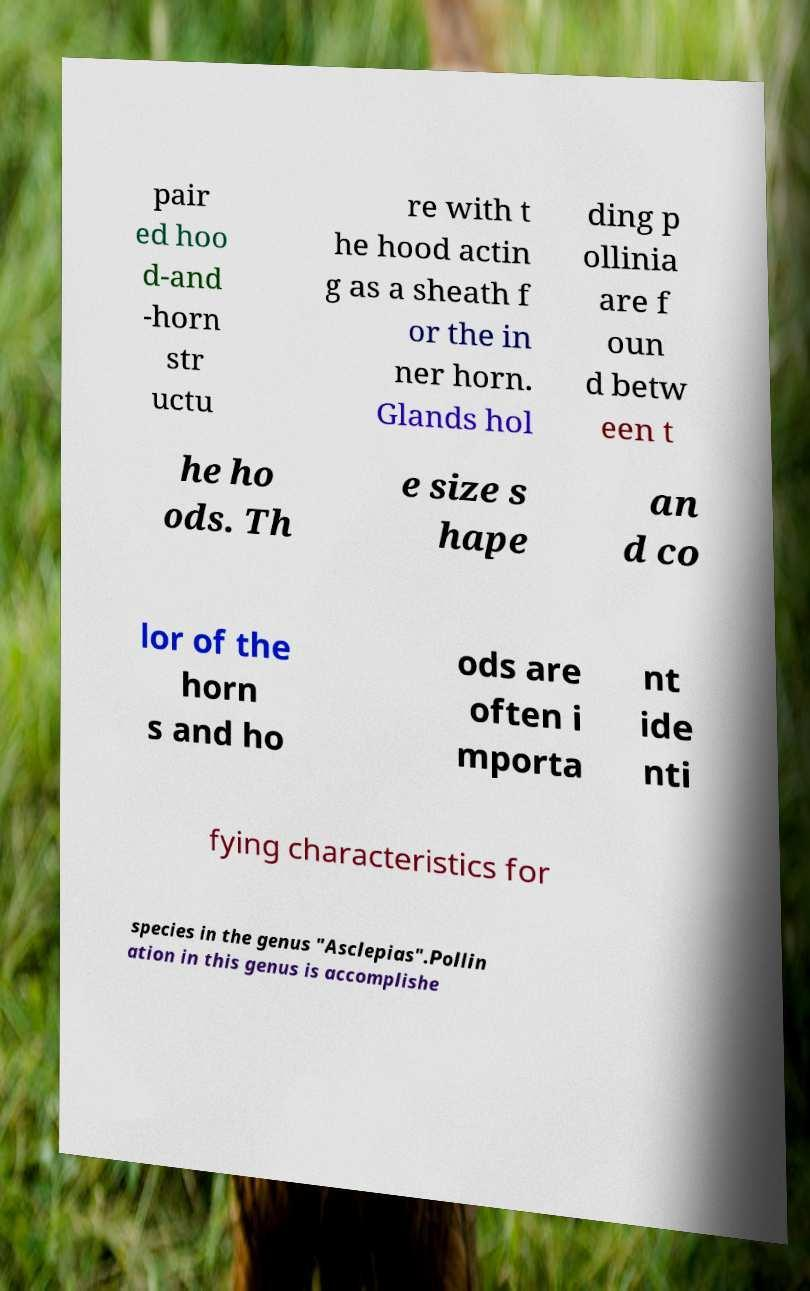Could you assist in decoding the text presented in this image and type it out clearly? pair ed hoo d-and -horn str uctu re with t he hood actin g as a sheath f or the in ner horn. Glands hol ding p ollinia are f oun d betw een t he ho ods. Th e size s hape an d co lor of the horn s and ho ods are often i mporta nt ide nti fying characteristics for species in the genus "Asclepias".Pollin ation in this genus is accomplishe 